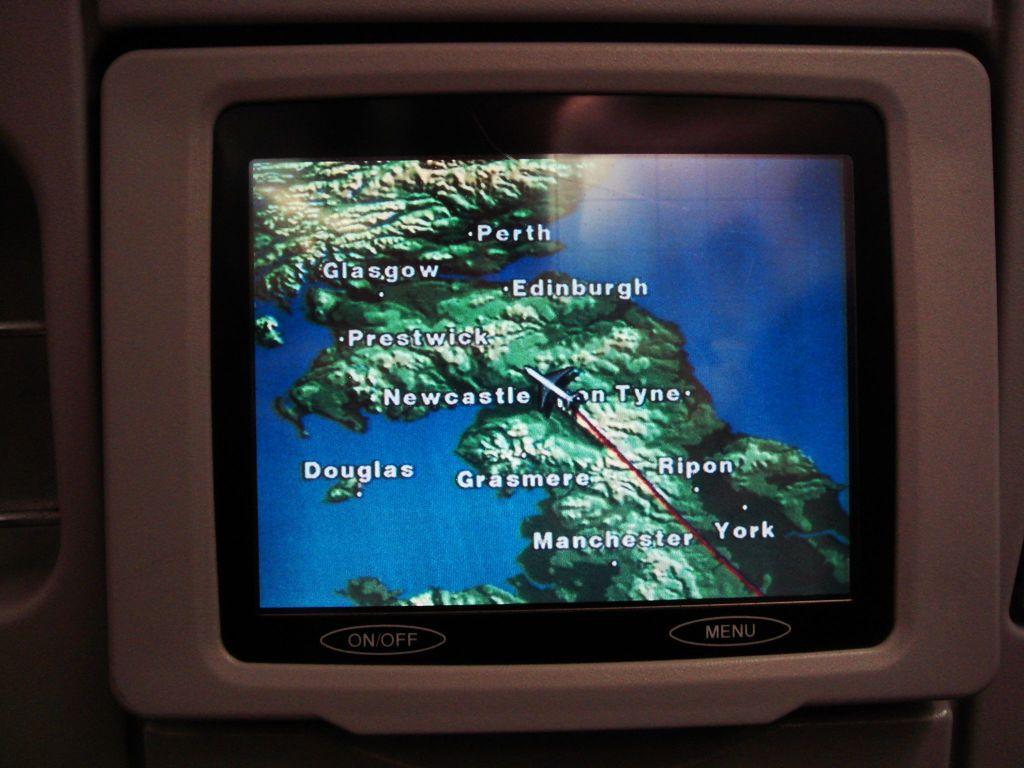<image>
Share a concise interpretation of the image provided. A weather map of the UK with Newcastle upon Tyne visible. 